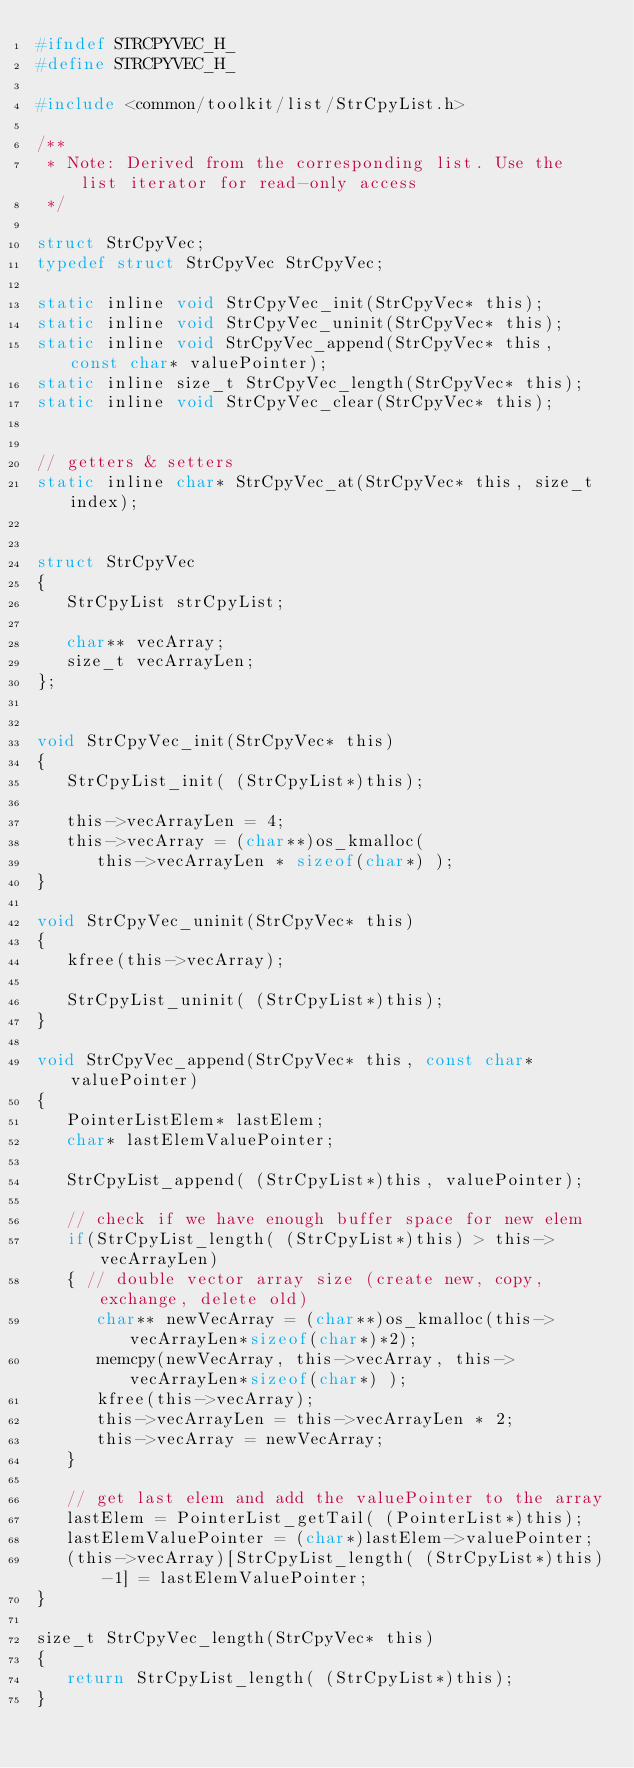Convert code to text. <code><loc_0><loc_0><loc_500><loc_500><_C_>#ifndef STRCPYVEC_H_
#define STRCPYVEC_H_

#include <common/toolkit/list/StrCpyList.h>

/**
 * Note: Derived from the corresponding list. Use the list iterator for read-only access
 */

struct StrCpyVec;
typedef struct StrCpyVec StrCpyVec;

static inline void StrCpyVec_init(StrCpyVec* this);
static inline void StrCpyVec_uninit(StrCpyVec* this);
static inline void StrCpyVec_append(StrCpyVec* this, const char* valuePointer);
static inline size_t StrCpyVec_length(StrCpyVec* this);
static inline void StrCpyVec_clear(StrCpyVec* this);


// getters & setters
static inline char* StrCpyVec_at(StrCpyVec* this, size_t index);


struct StrCpyVec
{
   StrCpyList strCpyList;

   char** vecArray;
   size_t vecArrayLen;
};


void StrCpyVec_init(StrCpyVec* this)
{
   StrCpyList_init( (StrCpyList*)this);

   this->vecArrayLen = 4;
   this->vecArray = (char**)os_kmalloc(
      this->vecArrayLen * sizeof(char*) );
}

void StrCpyVec_uninit(StrCpyVec* this)
{
   kfree(this->vecArray);

   StrCpyList_uninit( (StrCpyList*)this);
}

void StrCpyVec_append(StrCpyVec* this, const char* valuePointer)
{
   PointerListElem* lastElem;
   char* lastElemValuePointer;

   StrCpyList_append( (StrCpyList*)this, valuePointer);

   // check if we have enough buffer space for new elem
   if(StrCpyList_length( (StrCpyList*)this) > this->vecArrayLen)
   { // double vector array size (create new, copy, exchange, delete old)
      char** newVecArray = (char**)os_kmalloc(this->vecArrayLen*sizeof(char*)*2);
      memcpy(newVecArray, this->vecArray, this->vecArrayLen*sizeof(char*) );
      kfree(this->vecArray);
      this->vecArrayLen = this->vecArrayLen * 2;
      this->vecArray = newVecArray;
   }

   // get last elem and add the valuePointer to the array
   lastElem = PointerList_getTail( (PointerList*)this);
   lastElemValuePointer = (char*)lastElem->valuePointer;
   (this->vecArray)[StrCpyList_length( (StrCpyList*)this)-1] = lastElemValuePointer;
}

size_t StrCpyVec_length(StrCpyVec* this)
{
   return StrCpyList_length( (StrCpyList*)this);
}
</code> 